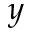<formula> <loc_0><loc_0><loc_500><loc_500>y</formula> 